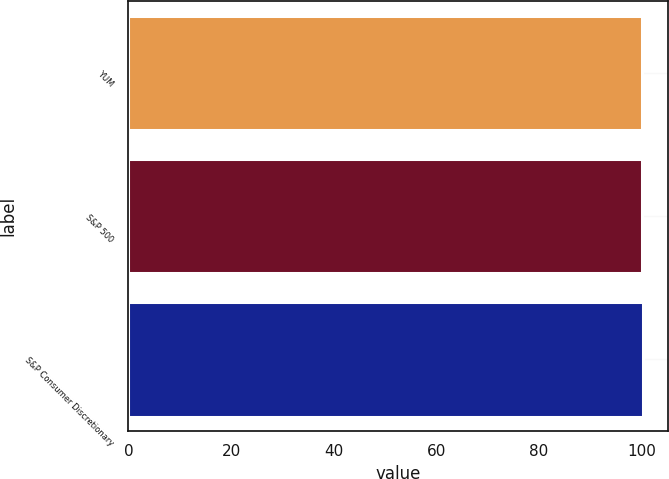Convert chart to OTSL. <chart><loc_0><loc_0><loc_500><loc_500><bar_chart><fcel>YUM<fcel>S&P 500<fcel>S&P Consumer Discretionary<nl><fcel>100<fcel>100.1<fcel>100.2<nl></chart> 